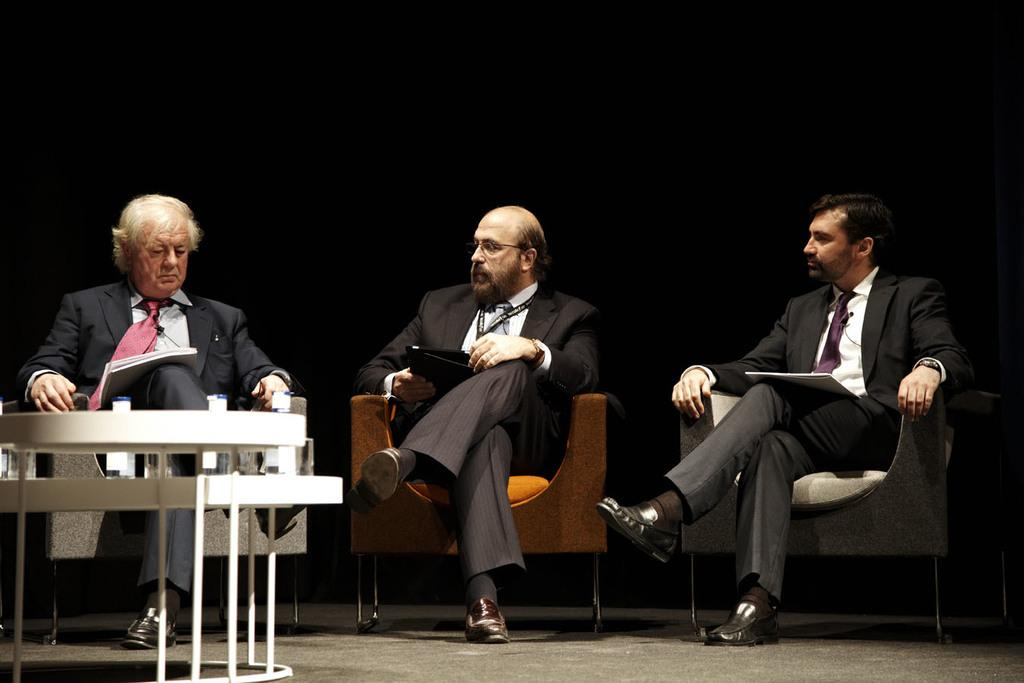What are the men in the image doing? The men in the image are sitting on chairs. What type of clothing are the men wearing? The men are wearing suits and ties. Can you describe any accessories the men are wearing? One of the men is wearing glasses (specs). What type of rose is the man holding in the image? There is no rose present in the image; the men are only wearing suits and ties, and one of them is wearing glasses. 